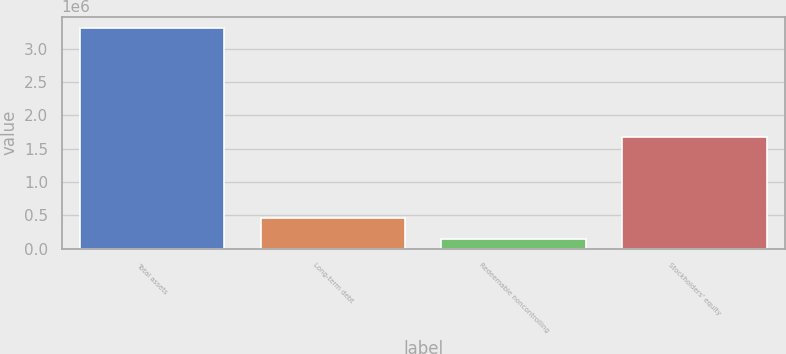<chart> <loc_0><loc_0><loc_500><loc_500><bar_chart><fcel>Total assets<fcel>Long-term debt<fcel>Redeemable noncontrolling<fcel>Stockholders' equity<nl><fcel>3.31347e+06<fcel>466372<fcel>150028<fcel>1.67499e+06<nl></chart> 